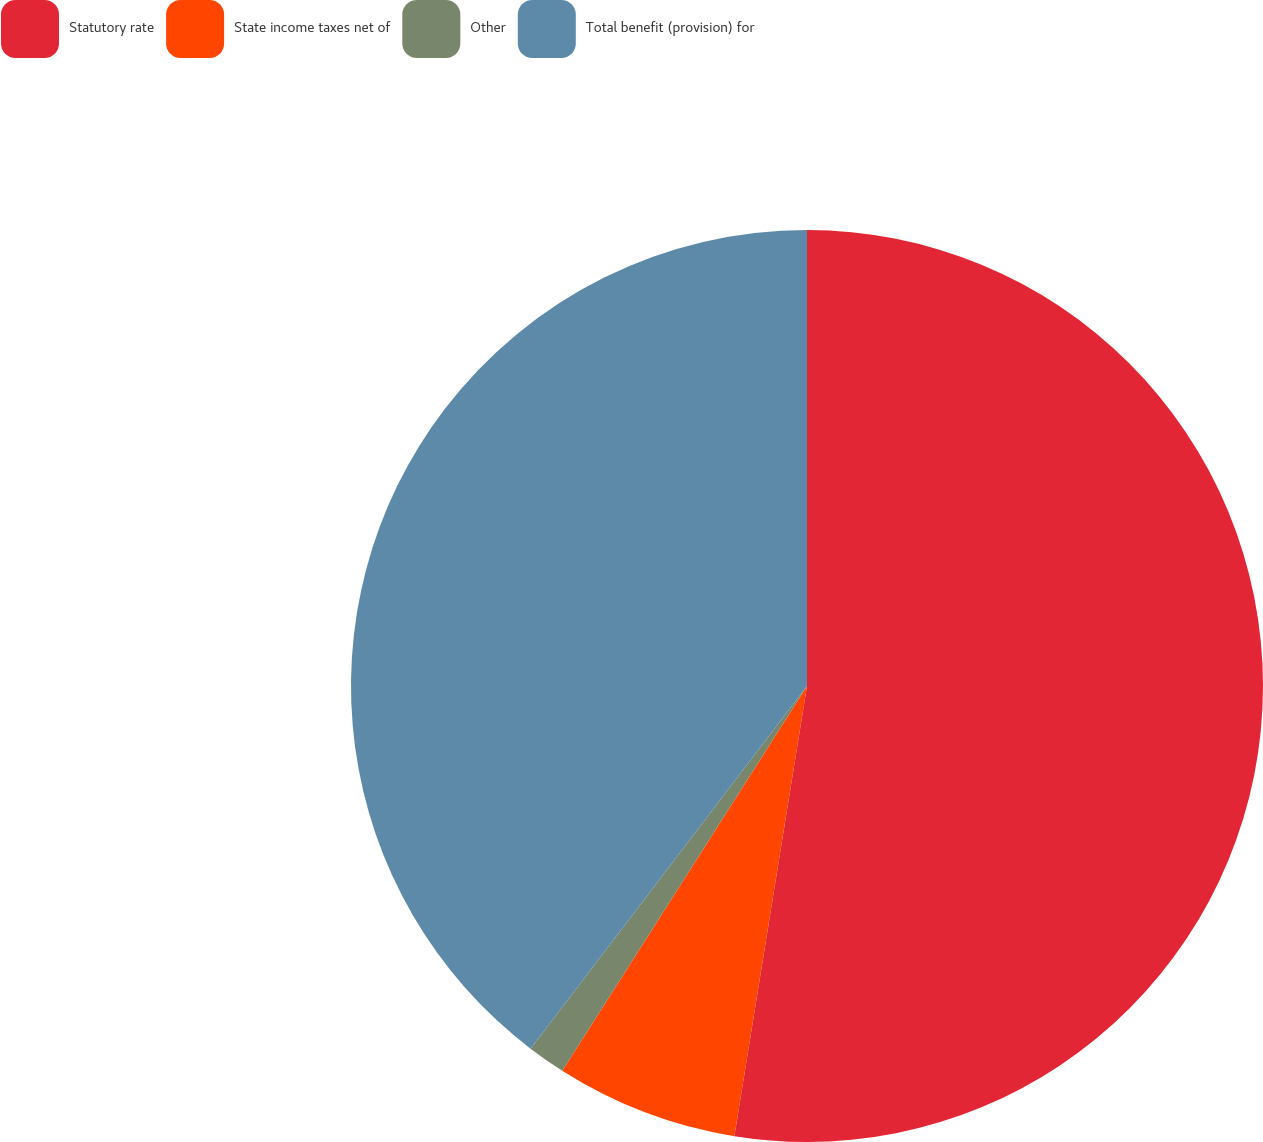Convert chart to OTSL. <chart><loc_0><loc_0><loc_500><loc_500><pie_chart><fcel>Statutory rate<fcel>State income taxes net of<fcel>Other<fcel>Total benefit (provision) for<nl><fcel>52.54%<fcel>6.47%<fcel>1.35%<fcel>39.63%<nl></chart> 